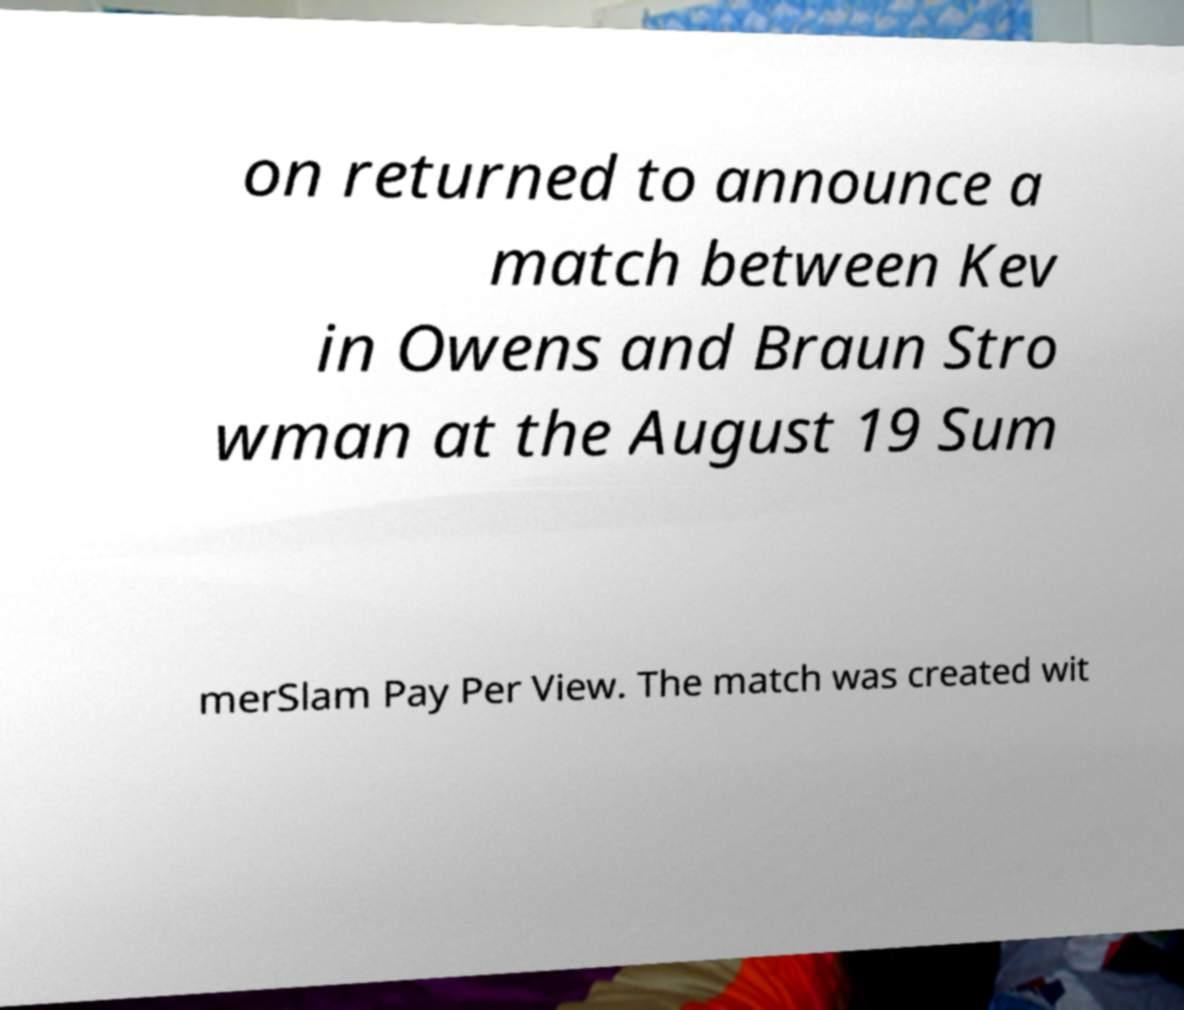Please read and relay the text visible in this image. What does it say? on returned to announce a match between Kev in Owens and Braun Stro wman at the August 19 Sum merSlam Pay Per View. The match was created wit 